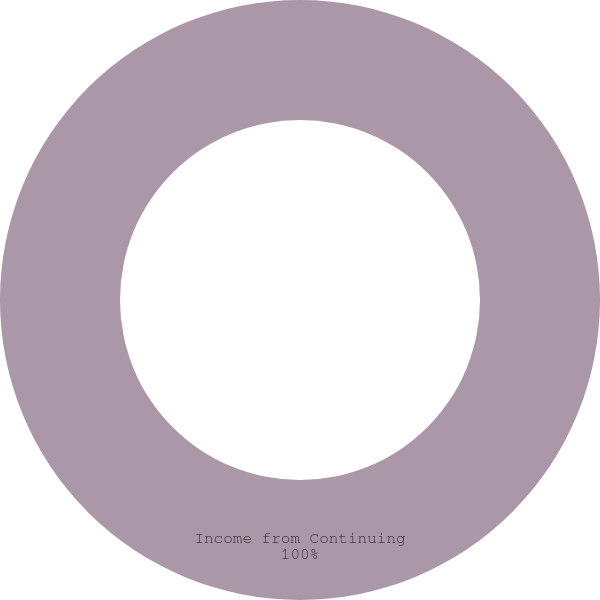Convert chart to OTSL. <chart><loc_0><loc_0><loc_500><loc_500><pie_chart><fcel>Income from Continuing<nl><fcel>100.0%<nl></chart> 